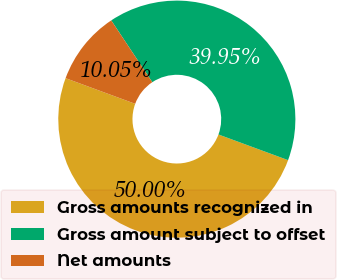<chart> <loc_0><loc_0><loc_500><loc_500><pie_chart><fcel>Gross amounts recognized in<fcel>Gross amount subject to offset<fcel>Net amounts<nl><fcel>50.0%<fcel>39.95%<fcel>10.05%<nl></chart> 